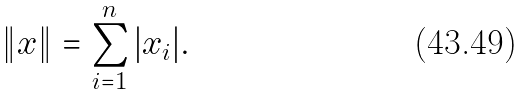Convert formula to latex. <formula><loc_0><loc_0><loc_500><loc_500>\| x \| = \sum _ { i = 1 } ^ { n } | x _ { i } | .</formula> 